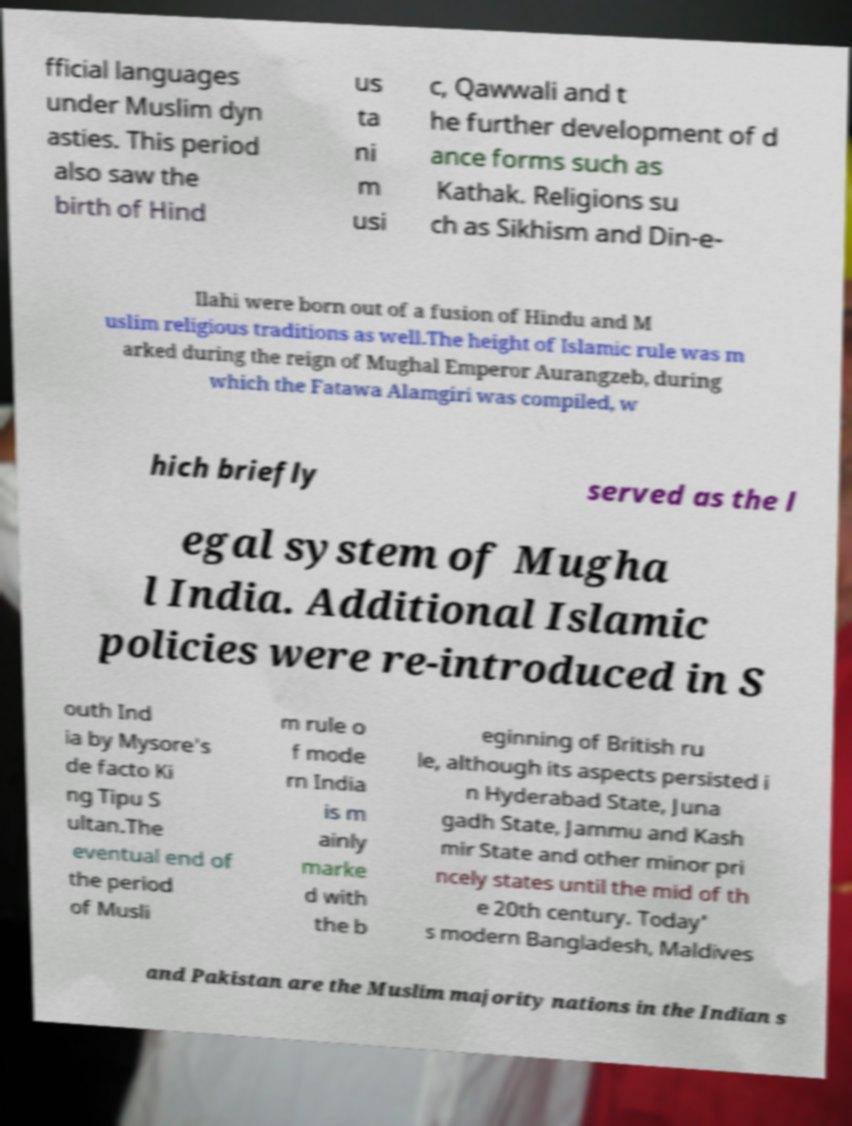Please identify and transcribe the text found in this image. fficial languages under Muslim dyn asties. This period also saw the birth of Hind us ta ni m usi c, Qawwali and t he further development of d ance forms such as Kathak. Religions su ch as Sikhism and Din-e- Ilahi were born out of a fusion of Hindu and M uslim religious traditions as well.The height of Islamic rule was m arked during the reign of Mughal Emperor Aurangzeb, during which the Fatawa Alamgiri was compiled, w hich briefly served as the l egal system of Mugha l India. Additional Islamic policies were re-introduced in S outh Ind ia by Mysore's de facto Ki ng Tipu S ultan.The eventual end of the period of Musli m rule o f mode rn India is m ainly marke d with the b eginning of British ru le, although its aspects persisted i n Hyderabad State, Juna gadh State, Jammu and Kash mir State and other minor pri ncely states until the mid of th e 20th century. Today' s modern Bangladesh, Maldives and Pakistan are the Muslim majority nations in the Indian s 